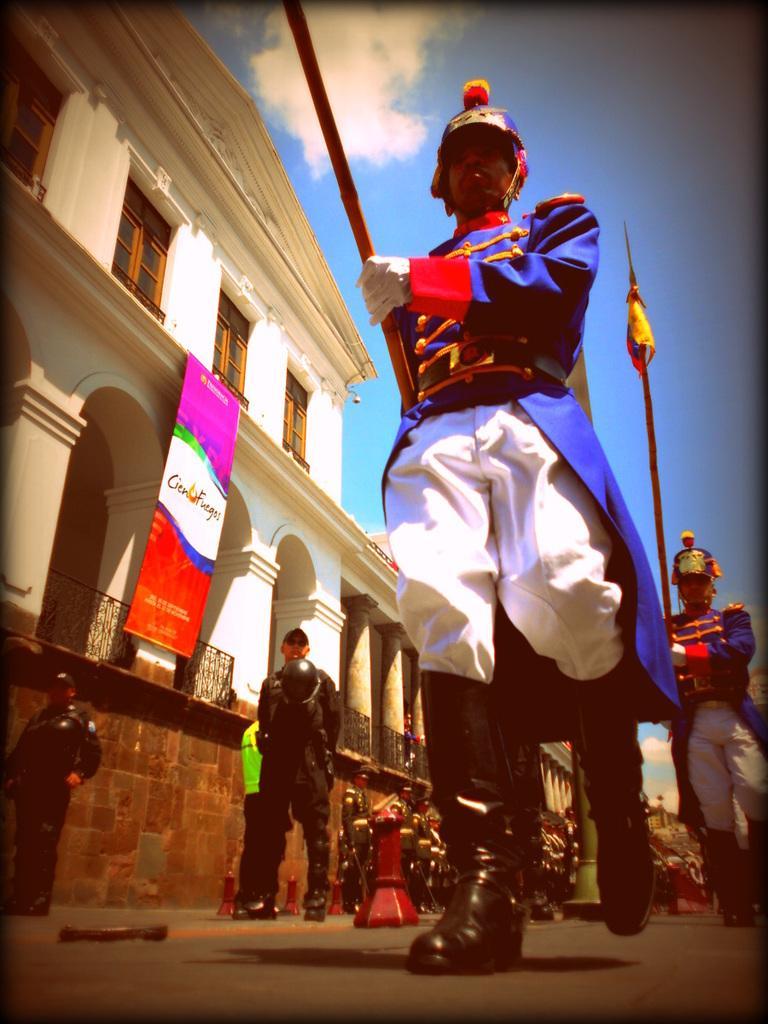How would you summarize this image in a sentence or two? At the right side of the image there are some persons wearing similar dress doing march fast and at the left side of the image there are some soldiers standing near the wall there is building to which flag is attached and at the top of the image there is clear sky. 